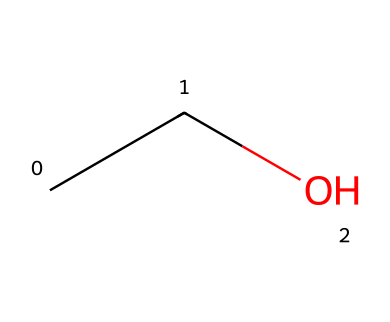What is the molecular formula of this compound? The SMILES representation "CCO" indicates that there are two carbon (C) atoms, six hydrogen (H) atoms, and one oxygen (O) atom present. The molecular formula can be derived directly from these counts: C2H6O.
Answer: C2H6O How many carbon atoms are in this molecule? By examining the SMILES "CCO", there are two 'C' characters, which indicate the presence of two carbon atoms in the structure.
Answer: 2 What type of compound is represented by this structure? The presence of a hydroxyl group (−OH) indicated by the 'O' in the SMILES denotes that it is an alcohol. Alcohols are organic compounds characterized by this functional group, making the structure an alcohol.
Answer: alcohol What is the state of matter for the compound at room temperature? Common alcohols, such as ethanol which corresponds to this structure, are typically liquid at room temperature. Given that the molecular structure suggests a small organic compound, the compound is expected to be a liquid.
Answer: liquid What type of bonding exists in this compound? The structure includes single bonds between the carbon atoms and between carbon and oxygen. Therefore, the compound exhibits covalent bonding, which is typical of organic compounds like alcohols.
Answer: covalent What is the role of this compound in breathalyzer tests? This alcohol (likely ethanol) is primarily what breathalyzers detect, as it evaporates easily into vapor from breath, making it a key target for measuring blood alcohol concentration.
Answer: ethanol 